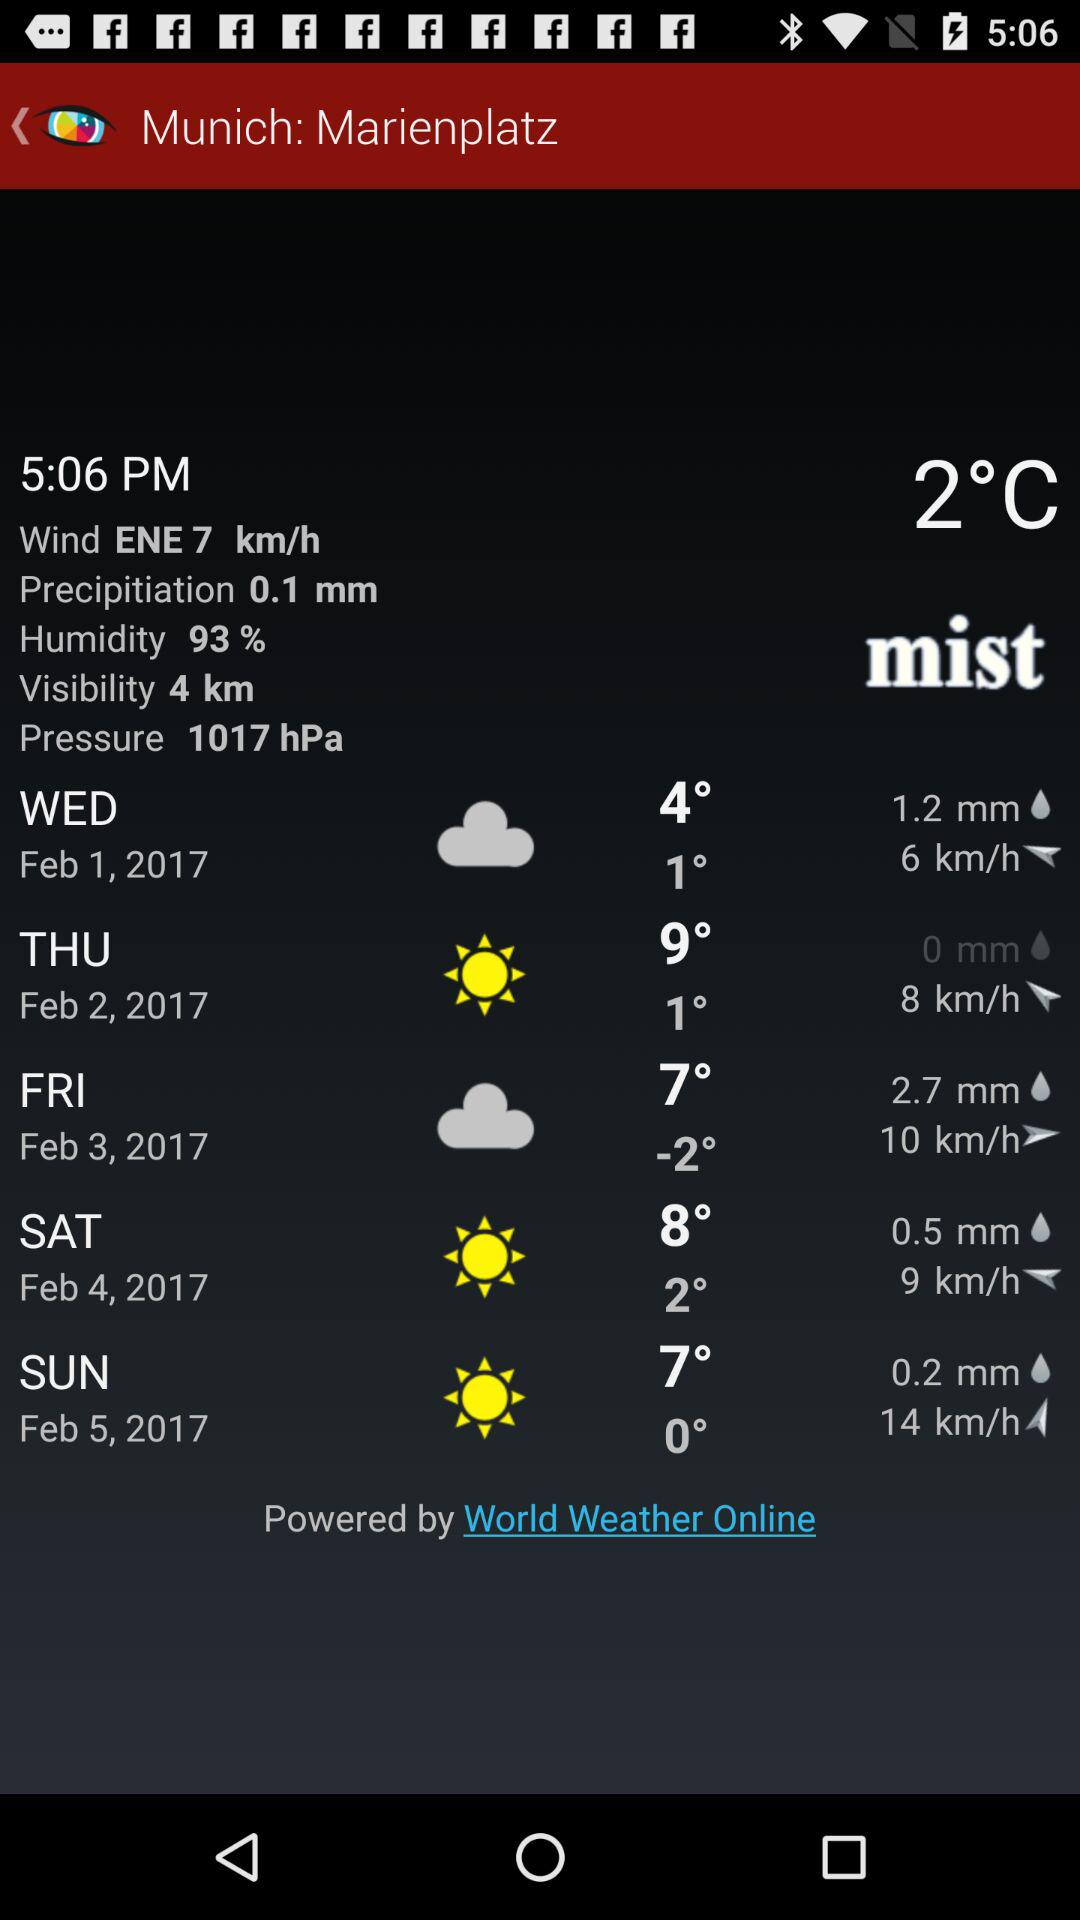What is the temperature on Sunday? The temperatures are 0° and 7° on Sunday. 